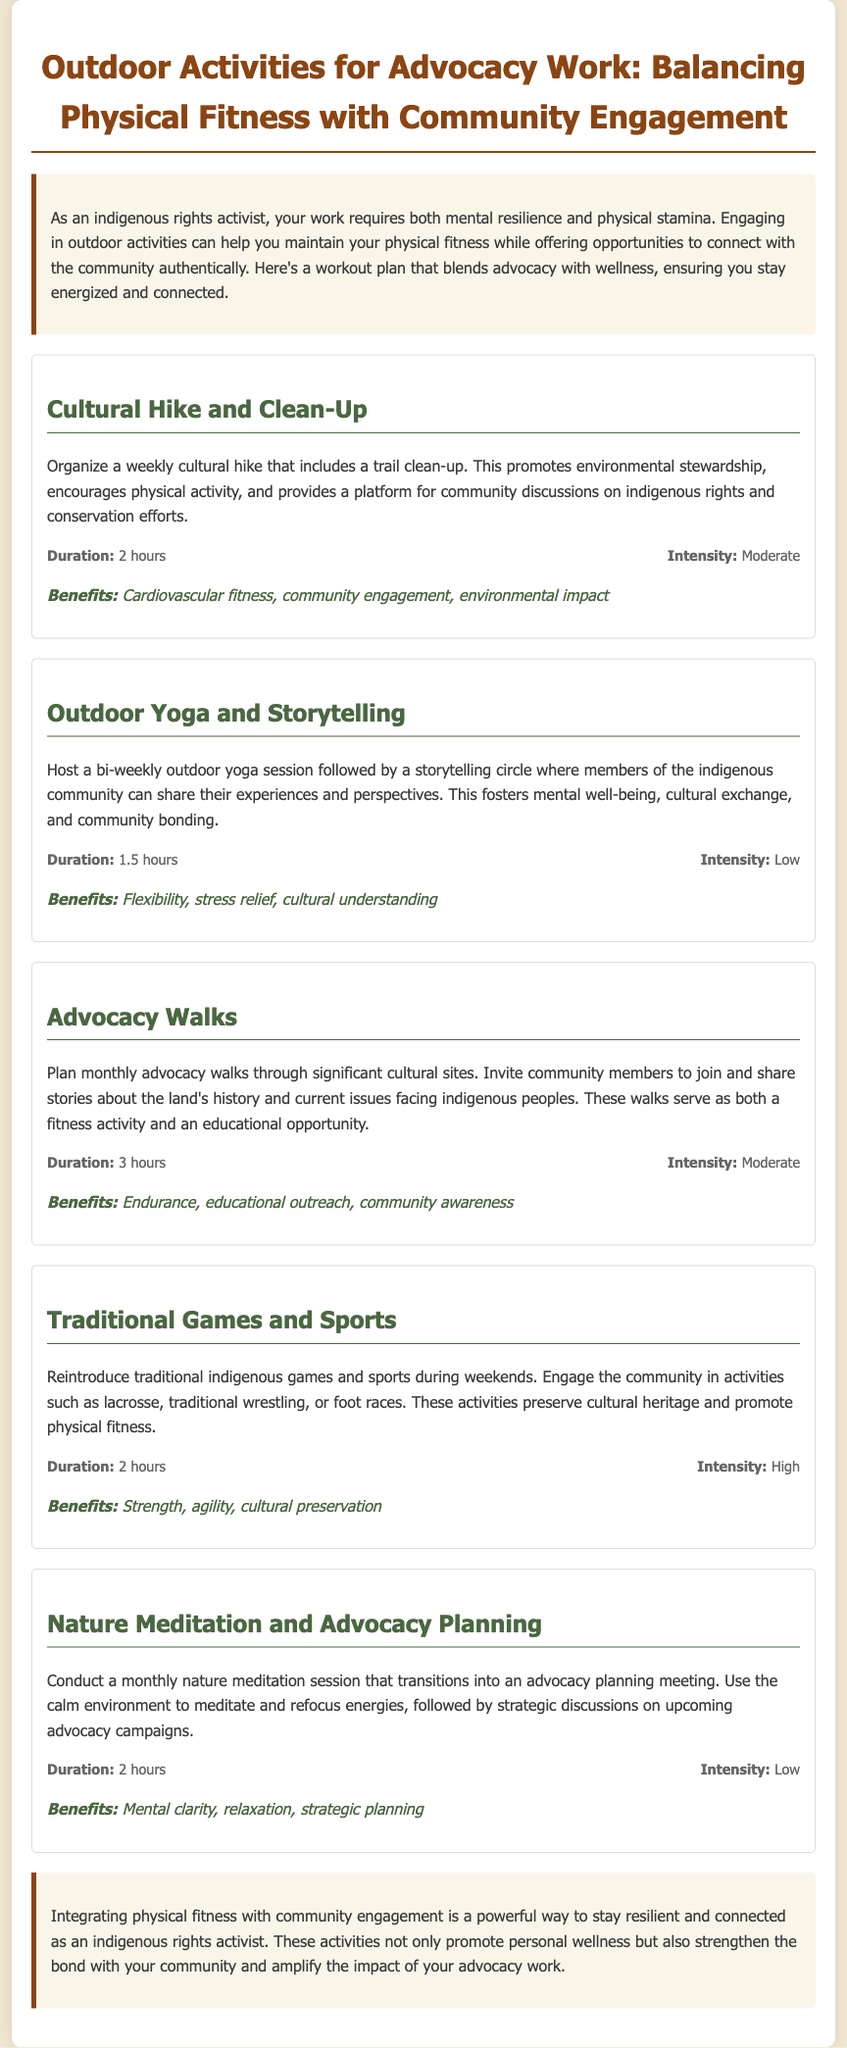What is the title of the document? The title is provided in the header of the document.
Answer: Outdoor Activities for Advocacy Work: Balancing Physical Fitness with Community Engagement How long is the Cultural Hike and Clean-Up activity? The duration is listed alongside the activity details in the document.
Answer: 2 hours What is the intensity level of Outdoor Yoga and Storytelling? The intensity is specified in the activity details of the Outdoor Yoga and Storytelling section.
Answer: Low What is one benefit of the Advocacy Walks? Benefits are described in the benefits section of the Advocacy Walks activity.
Answer: Educational outreach How often are Traditional Games and Sports scheduled? The frequency is implied within the description of the Traditional Games and Sports activity in the document.
Answer: Weekends What is the main purpose of the Nature Meditation and Advocacy Planning? The purpose is outlined in the description of the activity focusing on its dual objective.
Answer: Strategic discussions What type of fitness does the Cultural Hike and Clean-Up promote? The benefits section typically highlights what kind of fitness is promoted by the activity.
Answer: Cardiovascular fitness What activity combines physical fitness with storytelling? The specific activity that merges these elements is mentioned in the document.
Answer: Outdoor Yoga and Storytelling How long is the duration of the Advocacy Walks? The document mentions the duration in the activity details for Advocacy Walks.
Answer: 3 hours 